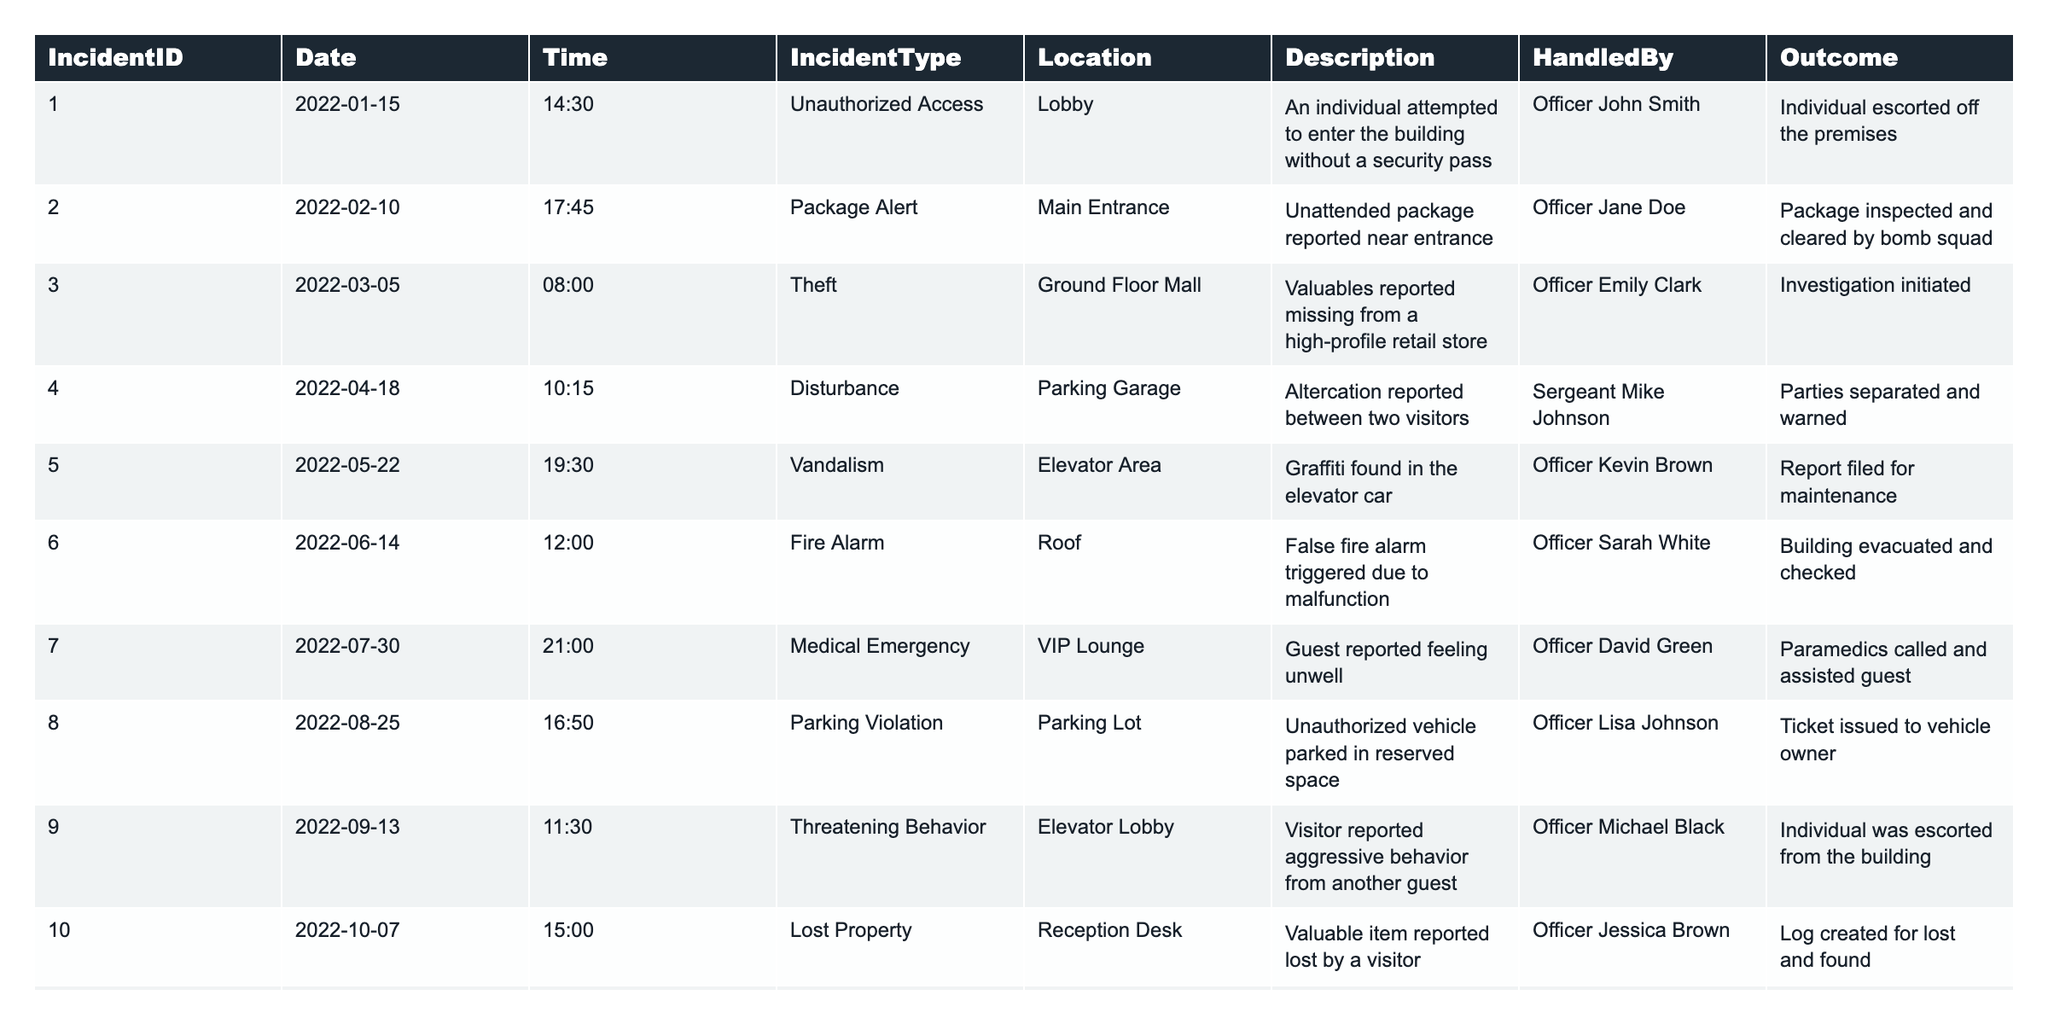What is the total number of incidents reported in the building for 2022? The table lists 12 incidents under the "IncidentID" column. Counting all entries, we see there are indeed 12 incidents reported.
Answer: 12 How many incidents involved unauthorized access? Upon examining the "IncidentType" column, there is 1 instance of unauthorized access listed under IncidentID 001.
Answer: 1 What was the outcome of the package alert incident? Referring to the row under the "IncidentType" of "Package Alert," the outcome indicates that the package was inspected and cleared by the bomb squad.
Answer: Package inspected and cleared by bomb squad Which type of incidents had the highest occurrence? By reviewing the "IncidentType" column, there are several types of incidents. Counting the distinct types, we find that both "Unauthorized Access" and "Fire Alarm" were the most reported, each occurring 1 time, which is quite low overall.
Answer: No type had multiple occurrences Did any incidents result in police involvement? There is no specific indication of police involvement in any of the outcomes shown in the table; thus, it can be concluded that none resulted in police being called.
Answer: No How many incidents were handled by Officer John Smith? Looking closely, Officer John Smith handled the "Unauthorized Access" incident (IncidentID 001). Thus, he handled 1 incident.
Answer: 1 What was the time of the medical emergency incident? The incident involving a medical emergency occurred at 21:00 on July 30, 2022, as stated in the table under the "Time" column.
Answer: 21:00 Which incident involved theft, and what was its outcome? By scanning the "IncidentType" column for "Theft," I find that IncidentID 003 involved theft, and the outcome was an investigation initiated.
Answer: Investigation initiated Was there any incident where the fire alarm was tested? Yes, according to the "IncidentType" column, there is a "Fire Alarm Test" incident listed under IncidentID 012.
Answer: Yes What is the date of the highest number of incidents reported if they were to be arranged monthly? After checking each month from January to December for the number of incidents, it turns out that all months have either 0 or 1 incident; thus, no month exceeded the others in number.
Answer: All months had 0 or 1 incident How many incidents involved a disturbance or threat? Upon reviewing the table, "Disturbance" appears once (IncidentID 004) and "Threatening Behavior" also appears once (IncidentID 009), totaling to 2 incidents involving disturbances or threats.
Answer: 2 